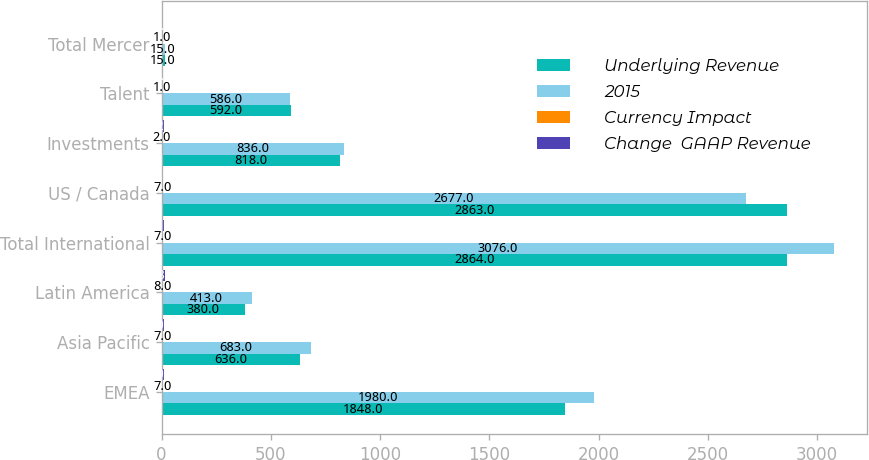<chart> <loc_0><loc_0><loc_500><loc_500><stacked_bar_chart><ecel><fcel>EMEA<fcel>Asia Pacific<fcel>Latin America<fcel>Total International<fcel>US / Canada<fcel>Investments<fcel>Talent<fcel>Total Mercer<nl><fcel>Underlying Revenue<fcel>1848<fcel>636<fcel>380<fcel>2864<fcel>2863<fcel>818<fcel>592<fcel>15<nl><fcel>2015<fcel>1980<fcel>683<fcel>413<fcel>3076<fcel>2677<fcel>836<fcel>586<fcel>15<nl><fcel>Currency Impact<fcel>7<fcel>7<fcel>8<fcel>7<fcel>7<fcel>2<fcel>1<fcel>1<nl><fcel>Change  GAAP Revenue<fcel>10<fcel>10<fcel>18<fcel>11<fcel>1<fcel>12<fcel>7<fcel>7<nl></chart> 